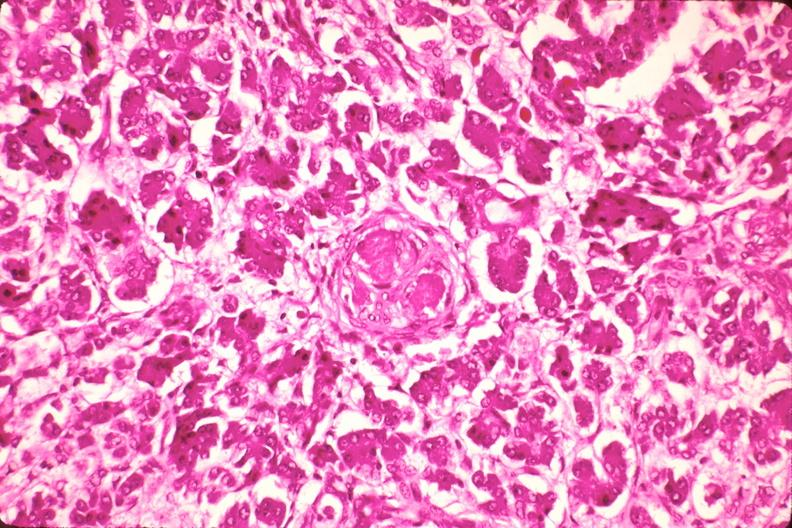s endocrine present?
Answer the question using a single word or phrase. Yes 